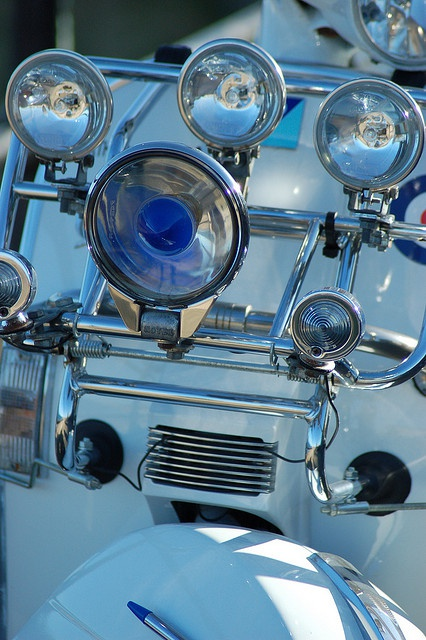Describe the objects in this image and their specific colors. I can see various objects in this image with different colors. 